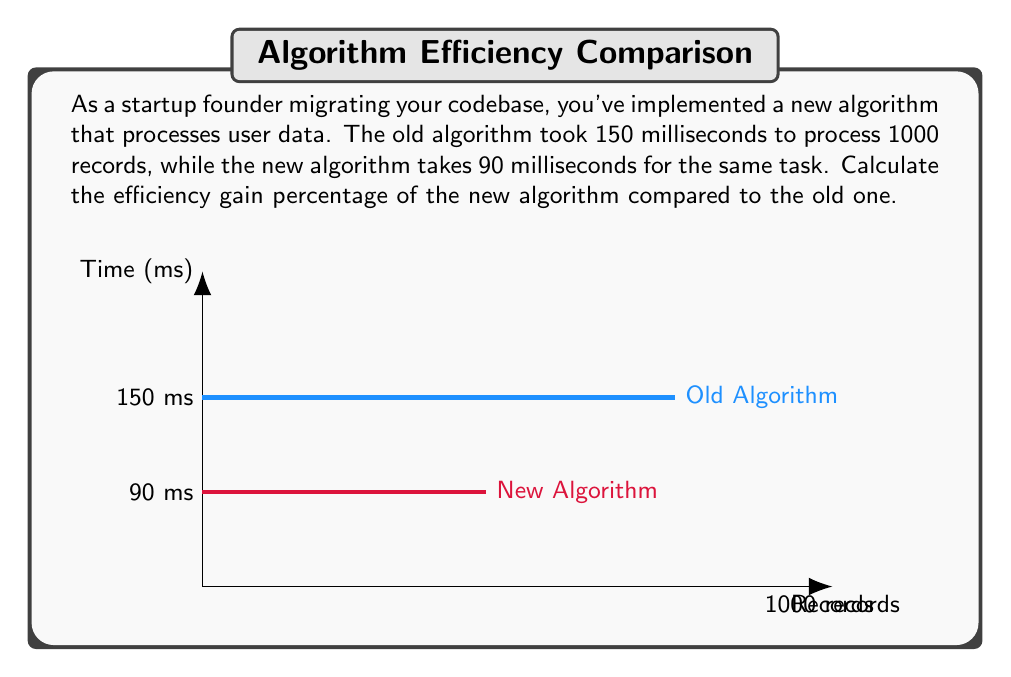What is the answer to this math problem? To calculate the efficiency gain percentage, we need to follow these steps:

1. Calculate the time saved:
   Time saved = Old time - New time
   $$ \text{Time saved} = 150 \text{ ms} - 90 \text{ ms} = 60 \text{ ms} $$

2. Calculate the efficiency gain as a fraction:
   Efficiency gain (fraction) = Time saved / Old time
   $$ \text{Efficiency gain (fraction)} = \frac{60 \text{ ms}}{150 \text{ ms}} = 0.4 $$

3. Convert the fraction to a percentage:
   Efficiency gain (percentage) = Efficiency gain (fraction) × 100%
   $$ \text{Efficiency gain (percentage)} = 0.4 \times 100\% = 40\% $$

Therefore, the efficiency gain percentage of the new algorithm compared to the old one is 40%.
Answer: 40% 